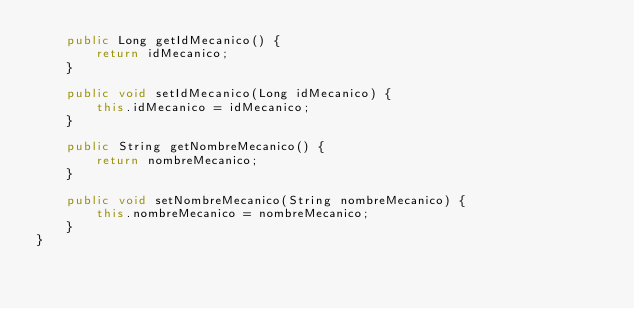Convert code to text. <code><loc_0><loc_0><loc_500><loc_500><_Java_>    public Long getIdMecanico() {
        return idMecanico;
    }

    public void setIdMecanico(Long idMecanico) {
        this.idMecanico = idMecanico;
    }

    public String getNombreMecanico() {
        return nombreMecanico;
    }

    public void setNombreMecanico(String nombreMecanico) {
        this.nombreMecanico = nombreMecanico;
    }
}
</code> 